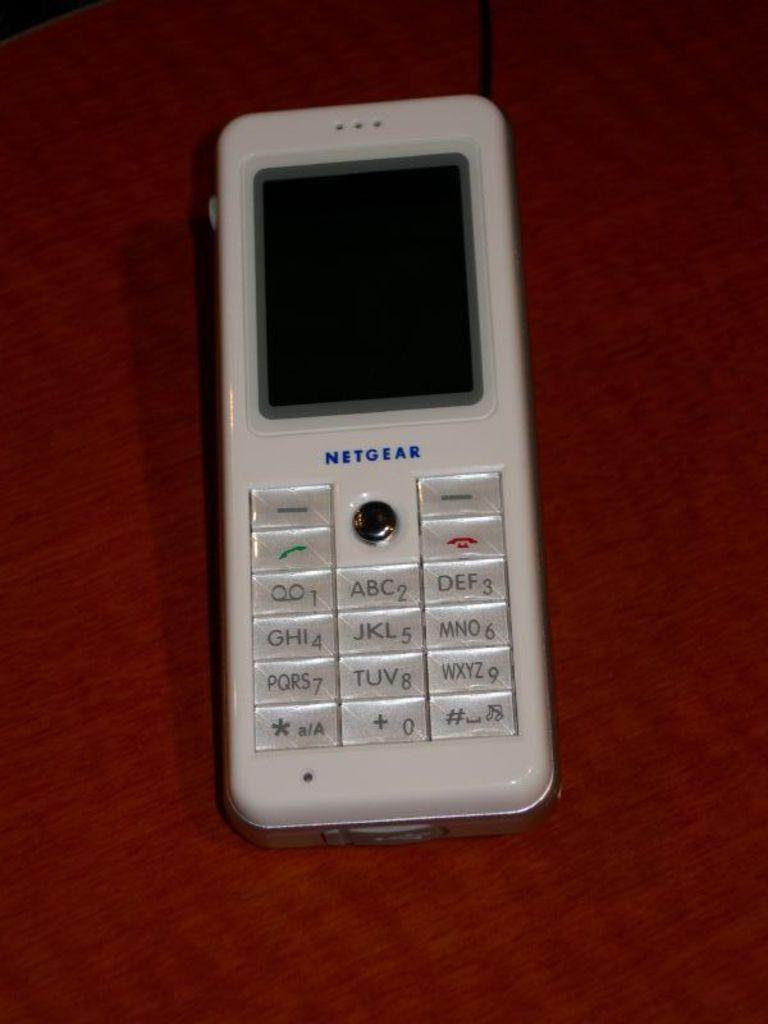Brand name of this phone?
Your response must be concise. Netgear. What letters are represented by the number 2?
Give a very brief answer. Abc. 